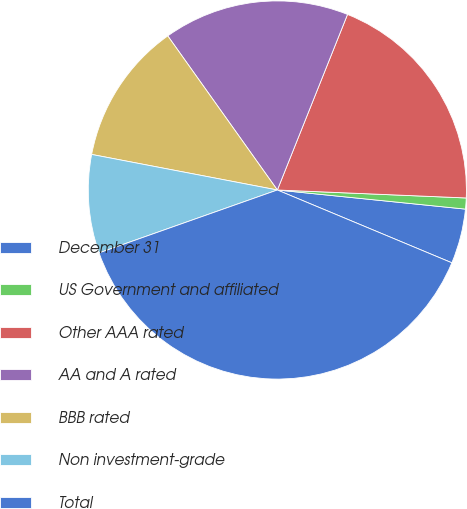Convert chart to OTSL. <chart><loc_0><loc_0><loc_500><loc_500><pie_chart><fcel>December 31<fcel>US Government and affiliated<fcel>Other AAA rated<fcel>AA and A rated<fcel>BBB rated<fcel>Non investment-grade<fcel>Total<nl><fcel>4.68%<fcel>0.94%<fcel>19.62%<fcel>15.89%<fcel>12.15%<fcel>8.41%<fcel>38.31%<nl></chart> 